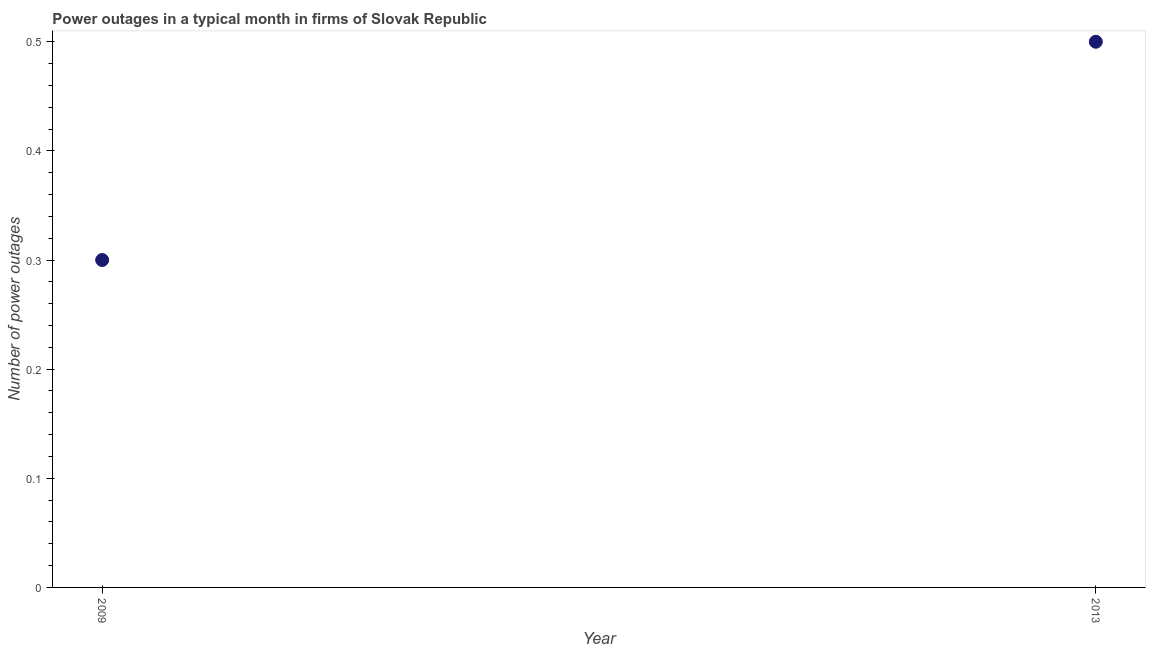Across all years, what is the maximum number of power outages?
Your response must be concise. 0.5. In which year was the number of power outages maximum?
Give a very brief answer. 2013. What is the sum of the number of power outages?
Offer a terse response. 0.8. What is the median number of power outages?
Provide a succinct answer. 0.4. Do a majority of the years between 2009 and 2013 (inclusive) have number of power outages greater than 0.32000000000000006 ?
Provide a succinct answer. No. Is the number of power outages in 2009 less than that in 2013?
Offer a terse response. Yes. In how many years, is the number of power outages greater than the average number of power outages taken over all years?
Your answer should be compact. 1. Does the number of power outages monotonically increase over the years?
Offer a terse response. Yes. How many dotlines are there?
Your answer should be very brief. 1. How many years are there in the graph?
Offer a terse response. 2. What is the difference between two consecutive major ticks on the Y-axis?
Give a very brief answer. 0.1. Are the values on the major ticks of Y-axis written in scientific E-notation?
Offer a very short reply. No. Does the graph contain any zero values?
Ensure brevity in your answer.  No. Does the graph contain grids?
Keep it short and to the point. No. What is the title of the graph?
Your answer should be very brief. Power outages in a typical month in firms of Slovak Republic. What is the label or title of the X-axis?
Your answer should be very brief. Year. What is the label or title of the Y-axis?
Ensure brevity in your answer.  Number of power outages. What is the Number of power outages in 2009?
Provide a short and direct response. 0.3. What is the difference between the Number of power outages in 2009 and 2013?
Provide a succinct answer. -0.2. 